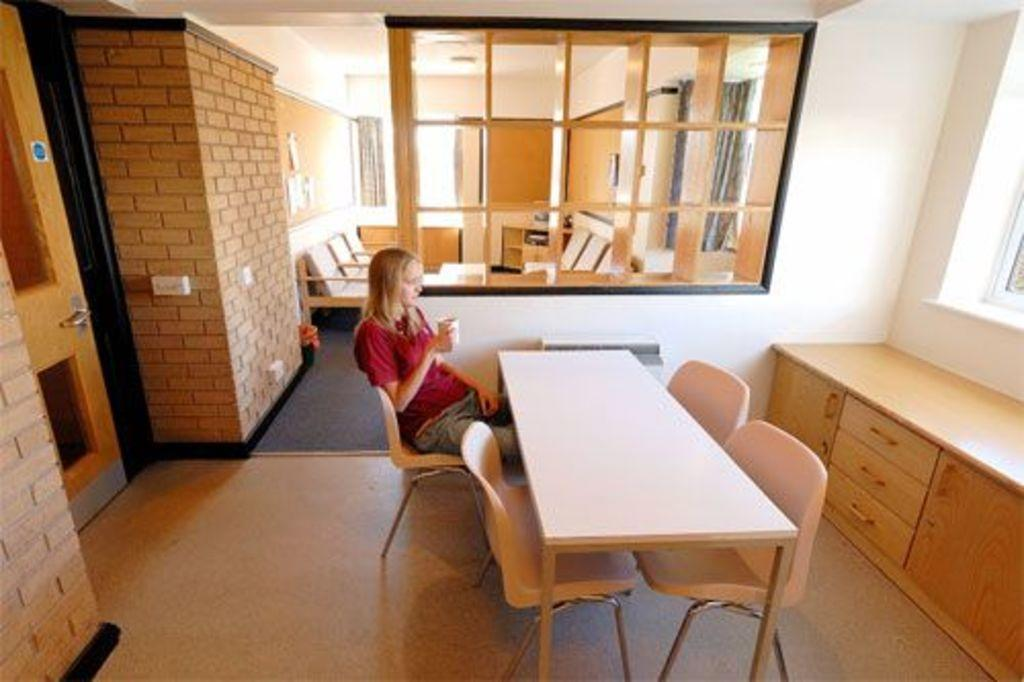Who is present in the room? There is a lady in the room. What is the lady wearing? The lady is wearing a red shirt. What is the lady doing in the room? The lady is sitting on a chair. What objects are in front of the lady? There is a table and a desk in front of the lady. What is the relationship between the lady's room and the adjacent room? There is another room beside the lady's room. How many flies are buzzing around the lady's head in the image? There are no flies present in the image. What type of girl is sitting next to the lady in the image? There is no girl present in the image; only the lady is mentioned. 